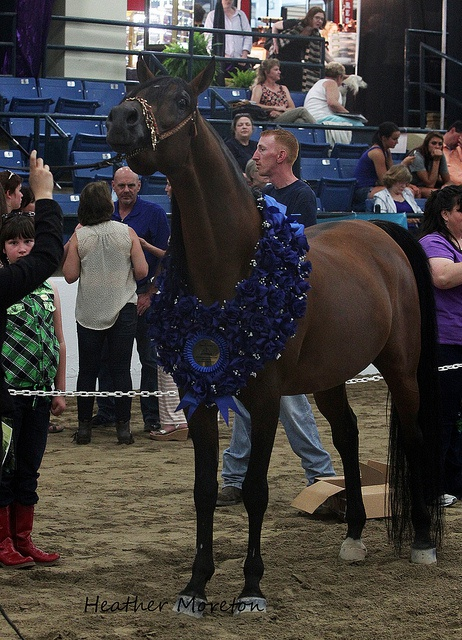Describe the objects in this image and their specific colors. I can see horse in black, gray, and maroon tones, people in black, gray, maroon, and darkgreen tones, people in black, gray, and darkgray tones, people in black, navy, maroon, and gray tones, and people in black, gray, and brown tones in this image. 